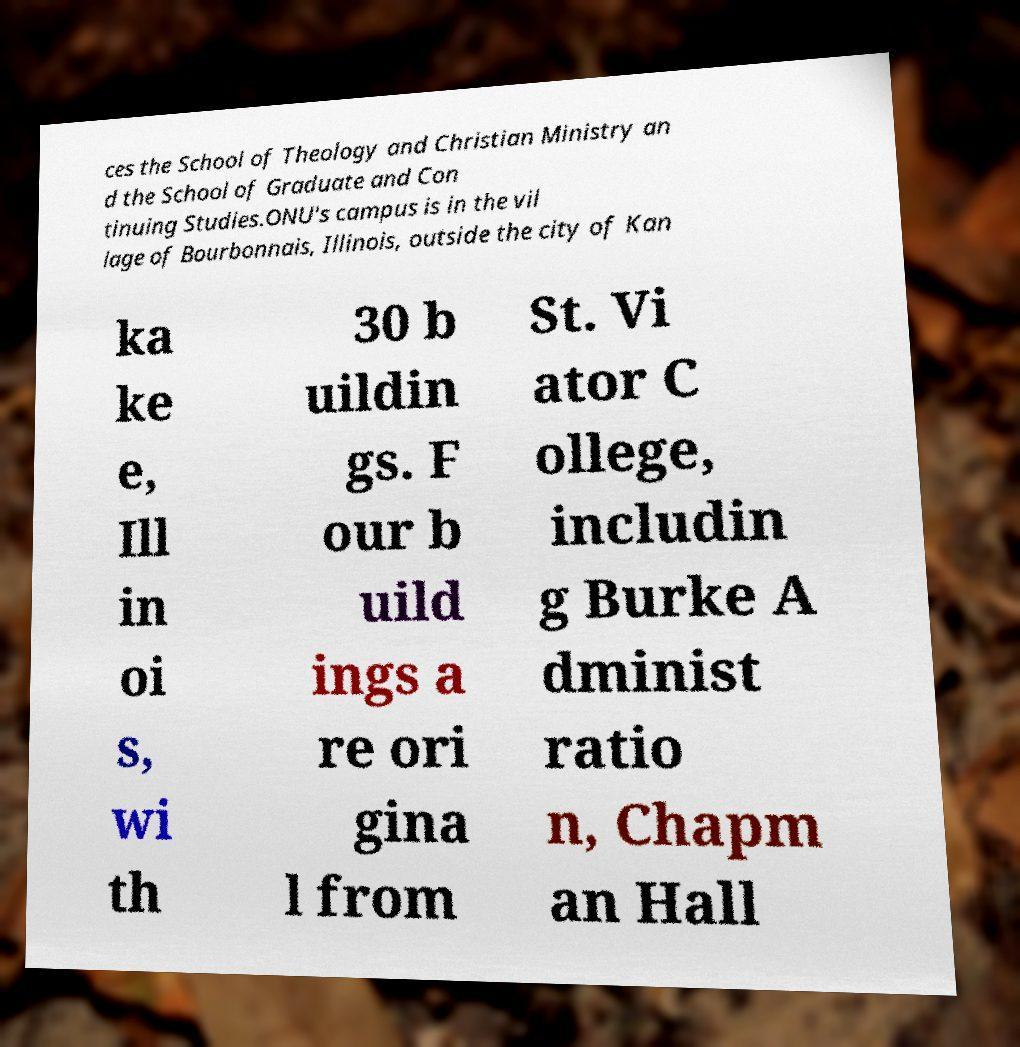I need the written content from this picture converted into text. Can you do that? ces the School of Theology and Christian Ministry an d the School of Graduate and Con tinuing Studies.ONU's campus is in the vil lage of Bourbonnais, Illinois, outside the city of Kan ka ke e, Ill in oi s, wi th 30 b uildin gs. F our b uild ings a re ori gina l from St. Vi ator C ollege, includin g Burke A dminist ratio n, Chapm an Hall 